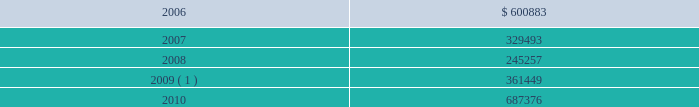During 2005 , we amended our $ 1.0 billion unsecured revolving credit facility to extend its maturity date from march 27 , 2008 to march 27 , 2010 , and reduce the effective interest rate to libor plus 1.0% ( 1.0 % ) and the commitment fee to 0.2% ( 0.2 % ) of the undrawn portion of the facility at december 31 , 2005 .
In addition , in 2005 , we entered into two $ 100.0 million unsecured term loans , due 2010 , at an effective interest rate of libor plus 0.8% ( 0.8 % ) at december 31 , 2005 .
During 2004 , we entered into an eight-year , $ 225.0 million unse- cured term loan , at libor plus 1.75% ( 1.75 % ) , which was amended in 2005 to reduce the effective interest rate to libor plus 1.0% ( 1.0 % ) at december 31 , 2005 .
The liquid yield option 2122 notes and the zero coupon convertible notes are unsecured zero coupon bonds with yields to maturity of 4.875% ( 4.875 % ) and 4.75% ( 4.75 % ) , respectively , due 2021 .
Each liquid yield option 2122 note and zero coupon convertible note was issued at a price of $ 381.63 and $ 391.06 , respectively , and will have a principal amount at maturity of $ 1000 .
Each liquid yield option 2122 note and zero coupon convertible note is convertible at the option of the holder into 11.7152 and 15.6675 shares of common stock , respec- tively , if the market price of our common stock reaches certain lev- els .
These conditions were met at december 31 , 2005 and 2004 for the zero coupon convertible notes and at december 31 , 2004 for the liquid yield option 2122 notes .
Since february 2 , 2005 , we have the right to redeem the liquid yield option 2122 notes and commencing on may 18 , 2006 , we will have the right to redeem the zero coupon con- vertible notes at their accreted values for cash as a whole at any time , or from time to time in part .
Holders may require us to pur- chase any outstanding liquid yield option 2122 notes at their accreted value on february 2 , 2011 and any outstanding zero coupon con- vertible notes at their accreted value on may 18 , 2009 and may 18 , 2014 .
We may choose to pay the purchase price in cash or common stock or a combination thereof .
During 2005 , holders of our liquid yield option 2122 notes and zero coupon convertible notes converted approximately $ 10.4 million and $ 285.0 million , respectively , of the accreted value of these notes into approximately 0.3 million and 9.4 million shares , respec- tively , of our common stock and cash for fractional shares .
In addi- tion , we called for redemption $ 182.3 million of the accreted bal- ance of outstanding liquid yield option 2122 notes .
Most holders of the liquid yield option 2122 notes elected to convert into shares of our common stock , rather than redeem for cash , resulting in the issuance of approximately 4.5 million shares .
During 2005 , we prepaid a total of $ 297.0 million on a term loan secured by a certain celebrity ship and on a variable rate unsecured term loan .
In 1996 , we entered into a $ 264.0 million capital lease to finance splendour of the seas and in 1995 we entered into a $ 260.0 million capital lease to finance legend of the seas .
During 2005 , we paid $ 335.8 million in connection with the exercise of purchase options on these capital lease obligations .
Under certain of our agreements , the contractual interest rate and commitment fee vary with our debt rating .
The unsecured senior notes and senior debentures are not redeemable prior to maturity .
Our debt agreements contain covenants that require us , among other things , to maintain minimum net worth and fixed charge cov- erage ratio and limit our debt to capital ratio .
We are in compliance with all covenants as of december 31 , 2005 .
Following is a schedule of annual maturities on long-term debt as of december 31 , 2005 for each of the next five years ( in thousands ) : .
1 the $ 137.9 million accreted value of the zero coupon convertible notes at december 31 , 2005 is included in year 2009 .
The holders of our zero coupon convertible notes may require us to purchase any notes outstanding at an accreted value of $ 161.7 mil- lion on may 18 , 2009 .
This accreted value was calculated based on the number of notes outstanding at december 31 , 2005 .
We may choose to pay any amounts in cash or common stock or a combination thereof .
Note 6 .
Shareholders 2019 equity on september 25 , 2005 , we announced that we and an investment bank had finalized a forward sale agreement relating to an asr transaction .
As part of the asr transaction , we purchased 5.5 million shares of our common stock from the investment bank at an initial price of $ 45.40 per share .
Total consideration paid to repurchase such shares , including commissions and other fees , was approxi- mately $ 249.1 million and was recorded in shareholders 2019 equity as a component of treasury stock .
The forward sale contract matured in february 2006 .
During the term of the forward sale contract , the investment bank purchased shares of our common stock in the open market to settle its obliga- tion related to the shares borrowed from third parties and sold to us .
Upon settlement of the contract , we received 218089 additional shares of our common stock .
These incremental shares will be recorded in shareholders 2019 equity as a component of treasury stock in the first quarter of 2006 .
Our employee stock purchase plan ( 201cespp 201d ) , which has been in effect since january 1 , 1994 , facilitates the purchase by employees of up to 800000 shares of common stock .
Offerings to employees are made on a quarterly basis .
Subject to certain limitations , the pur- chase price for each share of common stock is equal to 90% ( 90 % ) of the average of the market prices of the common stock as reported on the new york stock exchange on the first business day of the pur- chase period and the last business day of each month of the pur- chase period .
Shares of common stock of 14476 , 13281 and 21280 38 royal caribbean cruises ltd .
Notes to the consolidated financial statements ( continued ) .
What percentage of debt maturity was there in 2010 , relative to 2006? 
Computations: (100 * (687376 / 600883))
Answer: 114.39432. 